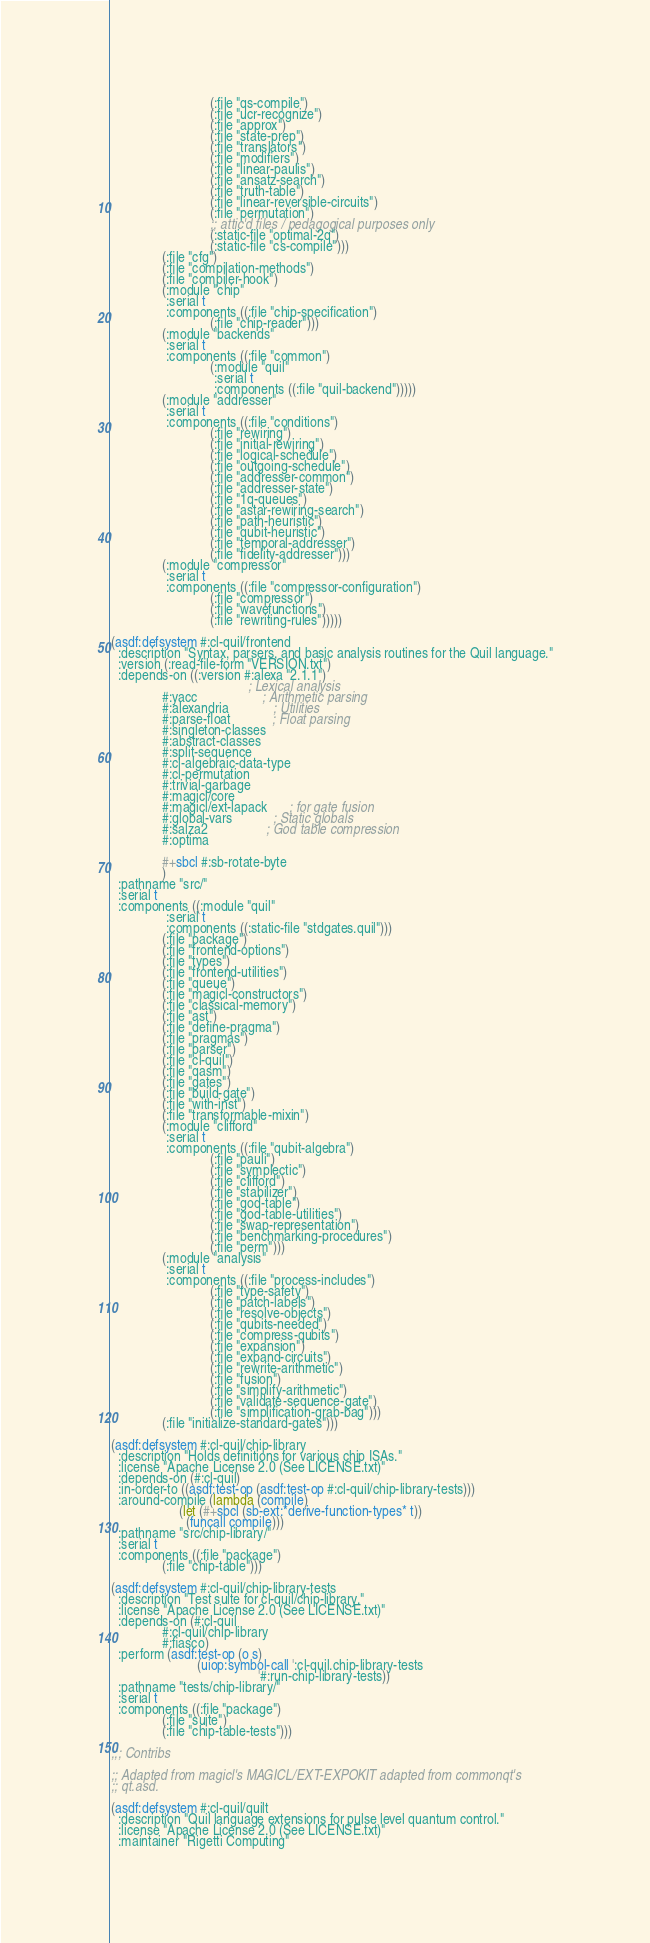<code> <loc_0><loc_0><loc_500><loc_500><_Lisp_>                             (:file "qs-compile")
                             (:file "ucr-recognize")
                             (:file "approx")
                             (:file "state-prep")
                             (:file "translators")
                             (:file "modifiers")
                             (:file "linear-paulis")
                             (:file "ansatz-search")
                             (:file "truth-table")
                             (:file "linear-reversible-circuits")
                             (:file "permutation")
                             ;; attic'd files / pedagogical purposes only
                             (:static-file "optimal-2q")
                             (:static-file "cs-compile")))
               (:file "cfg")
               (:file "compilation-methods")
               (:file "compiler-hook")
               (:module "chip"
                :serial t
                :components ((:file "chip-specification")
                             (:file "chip-reader")))
               (:module "backends"
                :serial t
                :components ((:file "common")
                             (:module "quil"
                              :serial t
                              :components ((:file "quil-backend")))))
               (:module "addresser"
                :serial t
                :components ((:file "conditions")
                             (:file "rewiring")
                             (:file "initial-rewiring")
                             (:file "logical-schedule")
                             (:file "outgoing-schedule")
                             (:file "addresser-common")
                             (:file "addresser-state")
                             (:file "1q-queues")
                             (:file "astar-rewiring-search")
                             (:file "path-heuristic")
                             (:file "qubit-heuristic")
                             (:file "temporal-addresser")
                             (:file "fidelity-addresser")))
               (:module "compressor"
                :serial t
                :components ((:file "compressor-configuration")
                             (:file "compressor")
                             (:file "wavefunctions")
                             (:file "rewriting-rules")))))

(asdf:defsystem #:cl-quil/frontend
  :description "Syntax, parsers, and basic analysis routines for the Quil language."
  :version (:read-file-form "VERSION.txt")
  :depends-on ((:version #:alexa "2.1.1")
                                        ; Lexical analysis
               #:yacc                   ; Arithmetic parsing
               #:alexandria             ; Utilities
               #:parse-float            ; Float parsing
               #:singleton-classes
               #:abstract-classes
               #:split-sequence
               #:cl-algebraic-data-type
               #:cl-permutation
               #:trivial-garbage
               #:magicl/core
               #:magicl/ext-lapack      ; for gate fusion
               #:global-vars            ; Static globals
               #:salza2                 ; God table compression
               #:optima

               #+sbcl #:sb-rotate-byte
               )
  :pathname "src/"
  :serial t
  :components ((:module "quil"
                :serial t
                :components ((:static-file "stdgates.quil")))
               (:file "package")
               (:file "frontend-options")
               (:file "types")
               (:file "frontend-utilities")
               (:file "queue")
               (:file "magicl-constructors")
               (:file "classical-memory")
               (:file "ast")
               (:file "define-pragma")
               (:file "pragmas")
               (:file "parser")
               (:file "cl-quil")
               (:file "qasm")
               (:file "gates")
               (:file "build-gate")
               (:file "with-inst")
               (:file "transformable-mixin") 
               (:module "clifford"
                :serial t
                :components ((:file "qubit-algebra")
                             (:file "pauli")
                             (:file "symplectic")
                             (:file "clifford")
                             (:file "stabilizer")
                             (:file "god-table")
                             (:file "god-table-utilities")
                             (:file "swap-representation")
                             (:file "benchmarking-procedures")
                             (:file "perm")))
               (:module "analysis"
                :serial t
                :components ((:file "process-includes")
                             (:file "type-safety")
                             (:file "patch-labels")
                             (:file "resolve-objects")
                             (:file "qubits-needed")
                             (:file "compress-qubits")
                             (:file "expansion")
                             (:file "expand-circuits")
                             (:file "rewrite-arithmetic")
                             (:file "fusion")
                             (:file "simplify-arithmetic")
                             (:file "validate-sequence-gate")
                             (:file "simplification-grab-bag")))
               (:file "initialize-standard-gates")))

(asdf:defsystem #:cl-quil/chip-library
  :description "Holds definitions for various chip ISAs."
  :license "Apache License 2.0 (See LICENSE.txt)"
  :depends-on (#:cl-quil)
  :in-order-to ((asdf:test-op (asdf:test-op #:cl-quil/chip-library-tests)))
  :around-compile (lambda (compile)
                    (let (#+sbcl (sb-ext:*derive-function-types* t))
                      (funcall compile)))
  :pathname "src/chip-library/"
  :serial t
  :components ((:file "package")
               (:file "chip-table")))

(asdf:defsystem #:cl-quil/chip-library-tests
  :description "Test suite for cl-quil/chip-library."
  :license "Apache License 2.0 (See LICENSE.txt)"
  :depends-on (#:cl-quil
               #:cl-quil/chip-library
               #:fiasco)
  :perform (asdf:test-op (o s)
                         (uiop:symbol-call ':cl-quil.chip-library-tests
                                           '#:run-chip-library-tests))
  :pathname "tests/chip-library/"
  :serial t
  :components ((:file "package")
               (:file "suite")
               (:file "chip-table-tests")))

;;; Contribs

;; Adapted from magicl's MAGICL/EXT-EXPOKIT adapted from commonqt's
;; qt.asd.

(asdf:defsystem #:cl-quil/quilt
  :description "Quil language extensions for pulse level quantum control."
  :license "Apache License 2.0 (See LICENSE.txt)"
  :maintainer "Rigetti Computing"</code> 